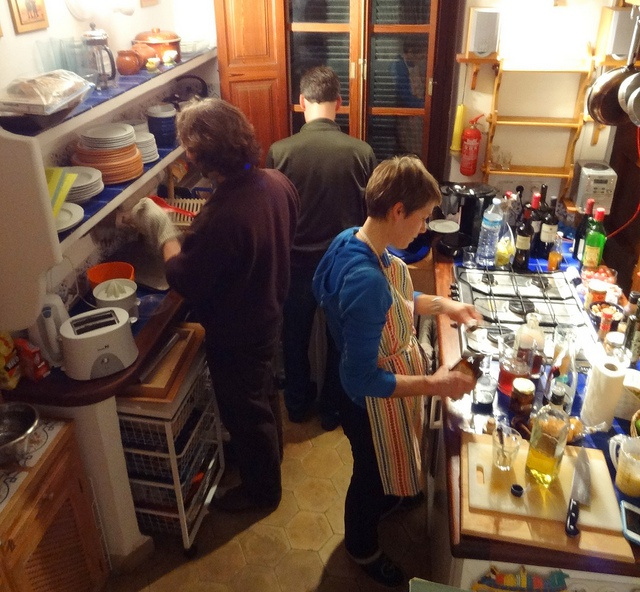Describe the objects in this image and their specific colors. I can see people in ivory, black, maroon, navy, and brown tones, people in ivory, black, maroon, gray, and brown tones, people in ivory, black, maroon, and gray tones, oven in ivory, darkgray, gray, and beige tones, and toaster in ivory, gray, maroon, and black tones in this image. 